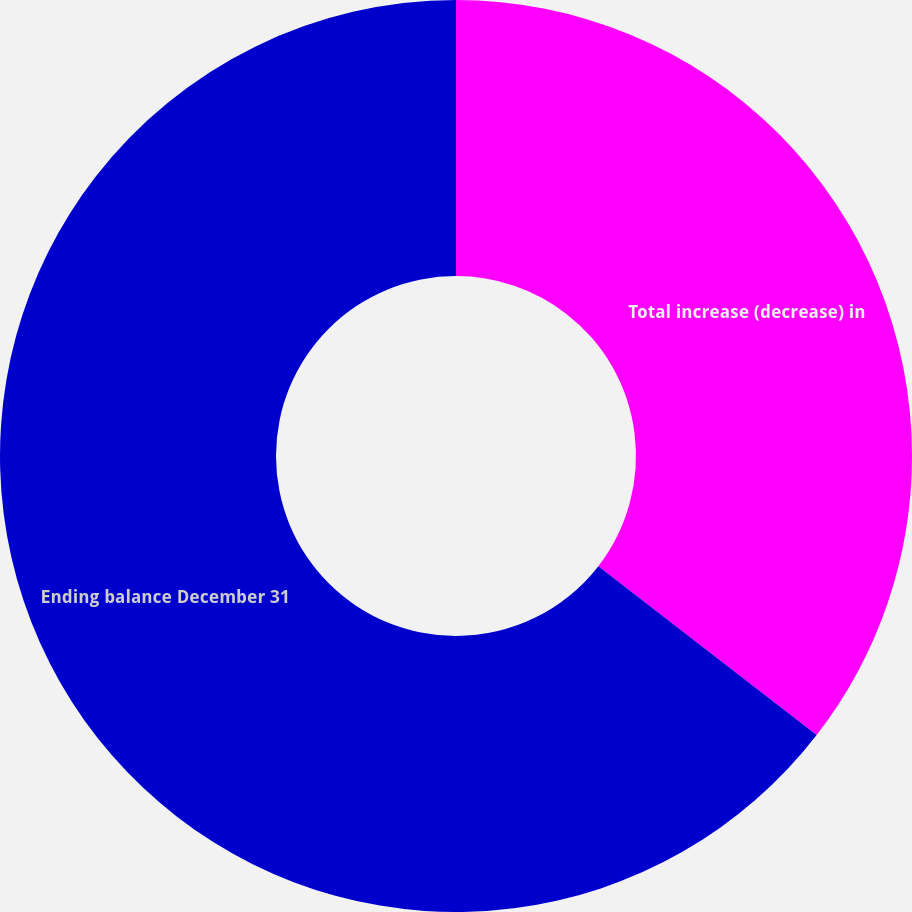Convert chart. <chart><loc_0><loc_0><loc_500><loc_500><pie_chart><fcel>Total increase (decrease) in<fcel>Ending balance December 31<nl><fcel>35.48%<fcel>64.52%<nl></chart> 